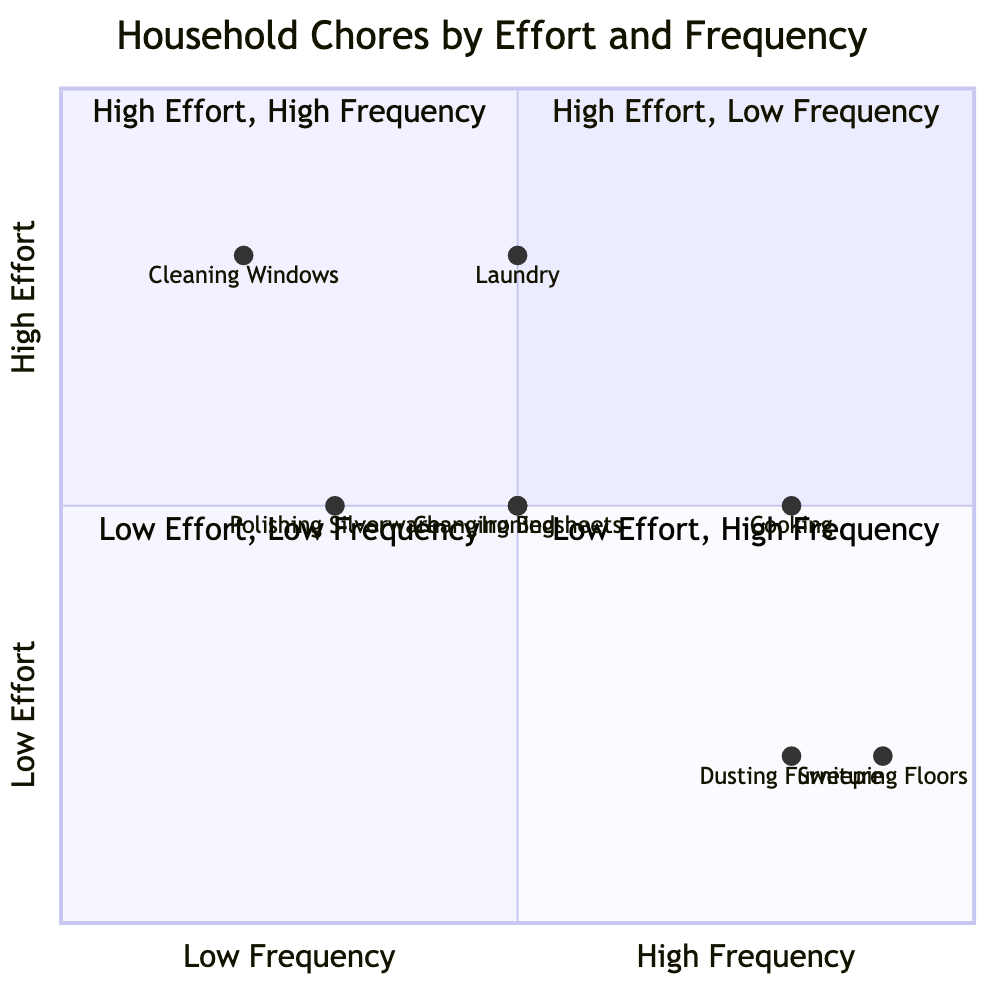What chore is in Quadrant 1? Quadrant 1 represents High Effort and Low Frequency. In the provided data, "Cleaning Windows" is located in this quadrant.
Answer: Cleaning Windows How many chores have High Frequency? To find the number of chores with High Frequency, we look at those in Quadrant 2 and Quadrant 4. The chores are "Cooking," "Sweeping Floors," and "Dusting Furniture," making a total of three.
Answer: 3 What is the Effort level for "Laundry"? The data specifies that Laundry has a High Effort level. Thus, referring to its position in the diagram confirms this.
Answer: High Name a chore that has Medium Frequency and High Effort. "Laundry" is the only chore in the dataset that has both Medium Frequency and High Effort based on its placement in the diagram.
Answer: Laundry Which chore has Low Effort and Low Frequency? In the Quadrant representing Low Effort and Low Frequency, we find "Polishing Silverware." Noting its position confirms its categorization.
Answer: Polishing Silverware What is the relationship between "Cooking" and "Ironing" in terms of Effort? Both "Cooking" and "Ironing" have a Medium Effort level, as indicated in their respective categories in the chart.
Answer: Medium How many chores are in Quadrant 4? Quadrant 4 contains chores with Low Effort and High Frequency. Referring to the data, there are three: "Sweeping Floors," "Dusting Furniture," and "Cooking."
Answer: 3 Which chore has the highest effort according to the chart? The chart categorizes "Laundry" and "Cleaning Windows" both as High Effort, but since Laundry is also noted as Medium Frequency, it positions itself to indicate it's the highest effort usually done more frequently than Cleaning Windows.
Answer: Laundry What is the least frequent chore listed? The only chore categorized with Low Frequency in the provided data is "Cleaning Windows," as denoted by its placement in Quadrant 1.
Answer: Cleaning Windows 